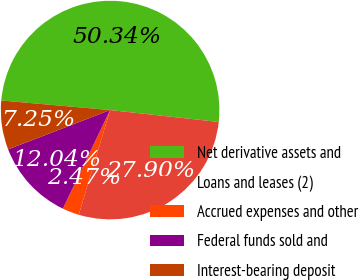Convert chart. <chart><loc_0><loc_0><loc_500><loc_500><pie_chart><fcel>Net derivative assets and<fcel>Loans and leases (2)<fcel>Accrued expenses and other<fcel>Federal funds sold and<fcel>Interest-bearing deposit<nl><fcel>50.34%<fcel>27.9%<fcel>2.47%<fcel>12.04%<fcel>7.25%<nl></chart> 